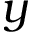<formula> <loc_0><loc_0><loc_500><loc_500>y</formula> 